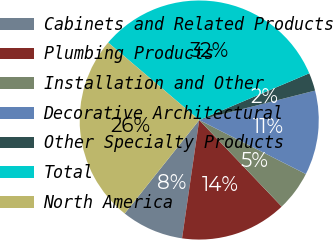Convert chart to OTSL. <chart><loc_0><loc_0><loc_500><loc_500><pie_chart><fcel>Cabinets and Related Products<fcel>Plumbing Products<fcel>Installation and Other<fcel>Decorative Architectural<fcel>Other Specialty Products<fcel>Total<fcel>North America<nl><fcel>8.42%<fcel>14.41%<fcel>5.42%<fcel>11.42%<fcel>2.43%<fcel>32.39%<fcel>25.5%<nl></chart> 